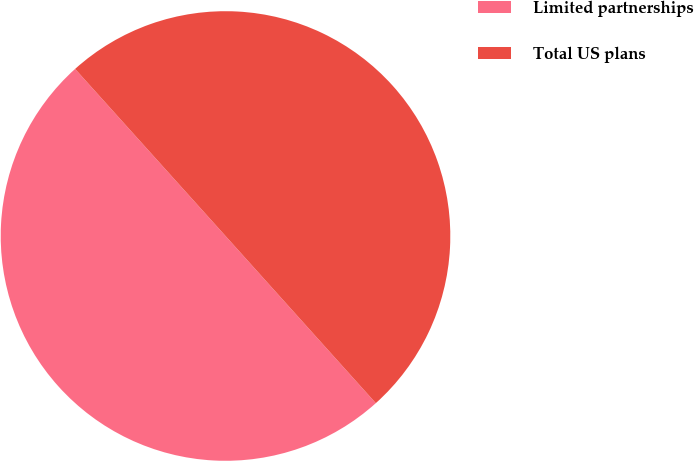Convert chart. <chart><loc_0><loc_0><loc_500><loc_500><pie_chart><fcel>Limited partnerships<fcel>Total US plans<nl><fcel>49.99%<fcel>50.01%<nl></chart> 